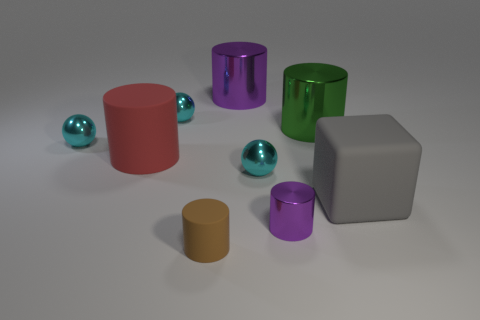There is a big object that is the same color as the tiny shiny cylinder; what is its shape?
Make the answer very short. Cylinder. What color is the large thing that is the same material as the large block?
Provide a succinct answer. Red. Does the small purple thing have the same shape as the gray object?
Offer a very short reply. No. Is there a green cylinder that is in front of the large rubber thing to the left of the thing in front of the tiny purple cylinder?
Your response must be concise. No. How many small shiny balls have the same color as the large rubber cylinder?
Offer a very short reply. 0. There is a red matte object that is the same size as the green metal cylinder; what shape is it?
Offer a terse response. Cylinder. There is a brown cylinder; are there any brown cylinders on the left side of it?
Give a very brief answer. No. Do the green shiny thing and the brown thing have the same size?
Provide a succinct answer. No. The small metallic thing in front of the gray block has what shape?
Your response must be concise. Cylinder. Is there a gray rubber block of the same size as the brown cylinder?
Offer a terse response. No. 